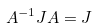Convert formula to latex. <formula><loc_0><loc_0><loc_500><loc_500>A ^ { - 1 } J A = J</formula> 